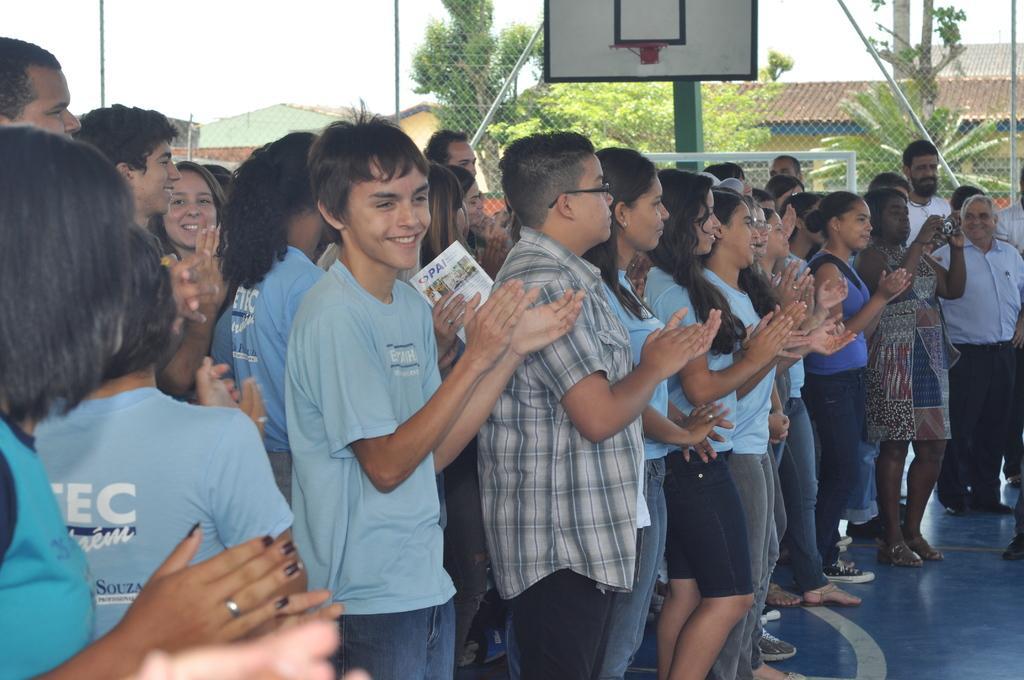In one or two sentences, can you explain what this image depicts? In this image we can see some people standing and among them few people are clapping their hands and there is a fence and in the background, we can see some trees and buildings. 